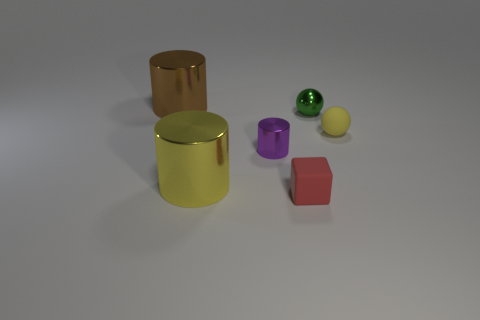Add 4 tiny blue blocks. How many objects exist? 10 Subtract all cubes. How many objects are left? 5 Subtract 0 gray balls. How many objects are left? 6 Subtract all tiny purple metal objects. Subtract all green metallic things. How many objects are left? 4 Add 5 big yellow metallic things. How many big yellow metallic things are left? 6 Add 5 large brown metallic blocks. How many large brown metallic blocks exist? 5 